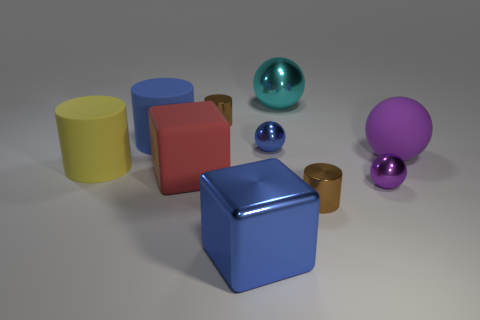Does the big cyan object have the same material as the yellow cylinder?
Ensure brevity in your answer.  No. How many other things are there of the same shape as the cyan metal thing?
Provide a short and direct response. 3. What is the color of the cylinder on the right side of the big metal object in front of the small brown cylinder on the right side of the big blue metallic thing?
Provide a short and direct response. Brown. Is the shape of the brown thing that is behind the large red block the same as  the large yellow rubber thing?
Provide a short and direct response. Yes. What number of tiny purple spheres are there?
Your answer should be compact. 1. How many yellow cubes are the same size as the blue rubber thing?
Your answer should be very brief. 0. What is the small purple thing made of?
Offer a terse response. Metal. There is a big rubber ball; is its color the same as the tiny shiny sphere right of the tiny blue metallic sphere?
Give a very brief answer. Yes. What is the size of the object that is both behind the large red rubber thing and on the right side of the big cyan shiny object?
Provide a short and direct response. Large. What shape is the red thing that is made of the same material as the yellow cylinder?
Provide a short and direct response. Cube. 